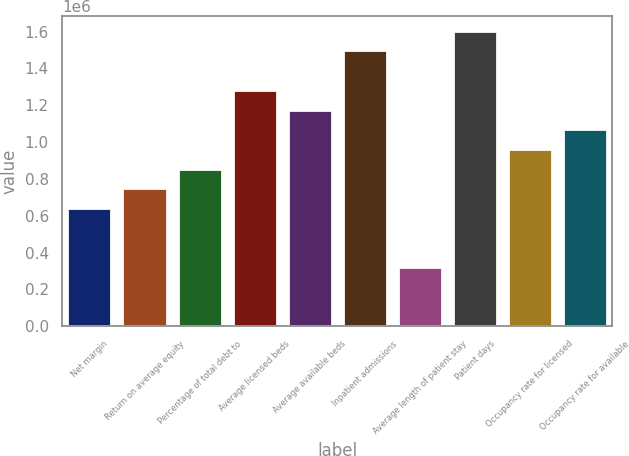Convert chart. <chart><loc_0><loc_0><loc_500><loc_500><bar_chart><fcel>Net margin<fcel>Return on average equity<fcel>Percentage of total debt to<fcel>Average licensed beds<fcel>Average available beds<fcel>Inpatient admissions<fcel>Average length of patient stay<fcel>Patient days<fcel>Occupancy rate for licensed<fcel>Occupancy rate for available<nl><fcel>641934<fcel>748923<fcel>855912<fcel>1.28387e+06<fcel>1.17688e+06<fcel>1.49785e+06<fcel>320967<fcel>1.60483e+06<fcel>962901<fcel>1.06989e+06<nl></chart> 